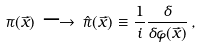<formula> <loc_0><loc_0><loc_500><loc_500>\pi ( \vec { x } ) \, \longrightarrow \, \hat { \pi } ( \vec { x } ) \equiv \frac { 1 } { i } \frac { \delta } { \delta \varphi ( \vec { x } ) } \, ,</formula> 